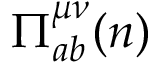<formula> <loc_0><loc_0><loc_500><loc_500>\Pi _ { a b } ^ { \mu \nu } ( n )</formula> 